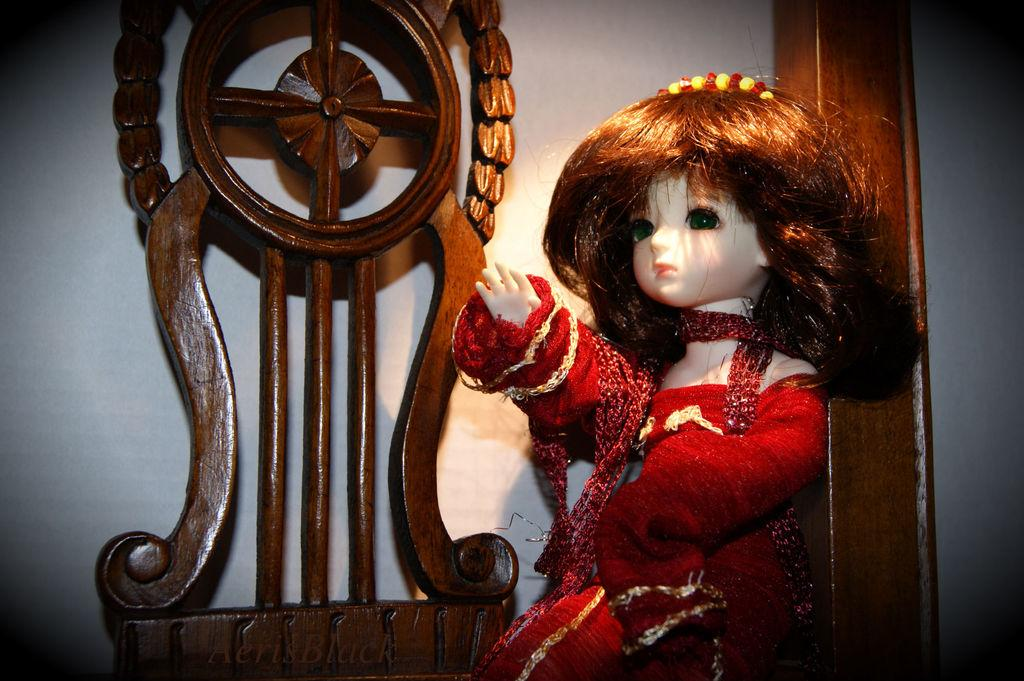What is the main subject of the image? There is a doll in the image. What other objects can be seen in the image? There is a wooden object and a pole in the image. What is visible in the background of the image? The sky is visible in the image. How many beads are attached to the doll's knee in the image? There are no beads or knees mentioned in the image, as it features a doll, a wooden object, and a pole. 